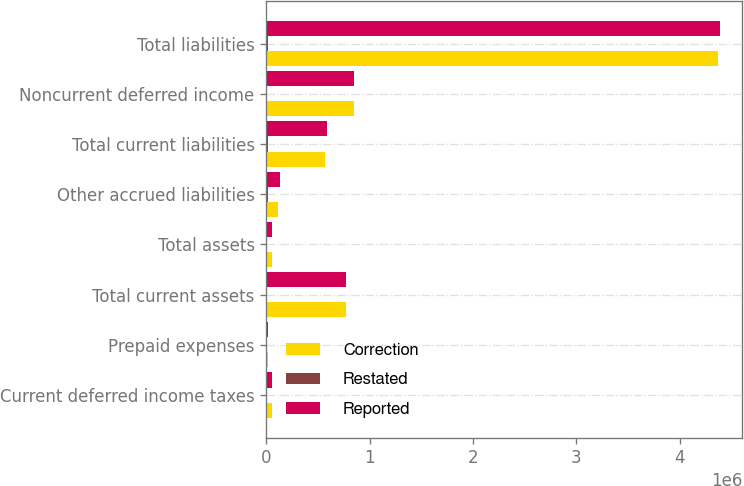<chart> <loc_0><loc_0><loc_500><loc_500><stacked_bar_chart><ecel><fcel>Current deferred income taxes<fcel>Prepaid expenses<fcel>Total current assets<fcel>Total assets<fcel>Other accrued liabilities<fcel>Total current liabilities<fcel>Noncurrent deferred income<fcel>Total liabilities<nl><fcel>Correction<fcel>53794<fcel>19374<fcel>772106<fcel>54249<fcel>112408<fcel>565672<fcel>849448<fcel>4.37291e+06<nl><fcel>Restated<fcel>910<fcel>735<fcel>1645<fcel>1645<fcel>16676<fcel>16676<fcel>5849<fcel>10827<nl><fcel>Reported<fcel>54704<fcel>20109<fcel>773751<fcel>54249<fcel>129084<fcel>582348<fcel>843599<fcel>4.38374e+06<nl></chart> 